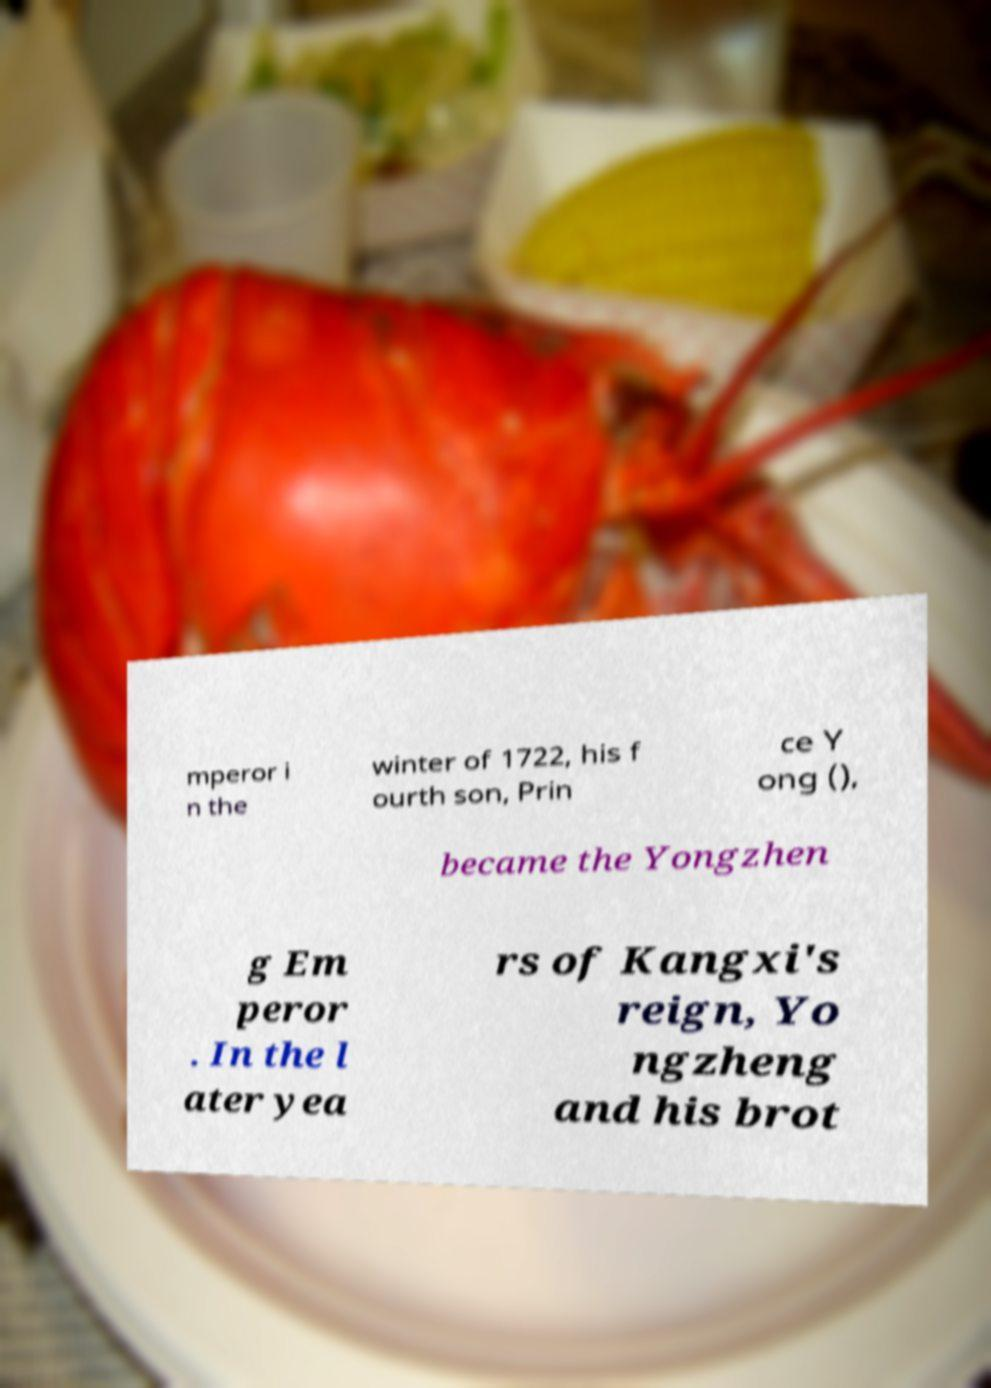For documentation purposes, I need the text within this image transcribed. Could you provide that? mperor i n the winter of 1722, his f ourth son, Prin ce Y ong (), became the Yongzhen g Em peror . In the l ater yea rs of Kangxi's reign, Yo ngzheng and his brot 